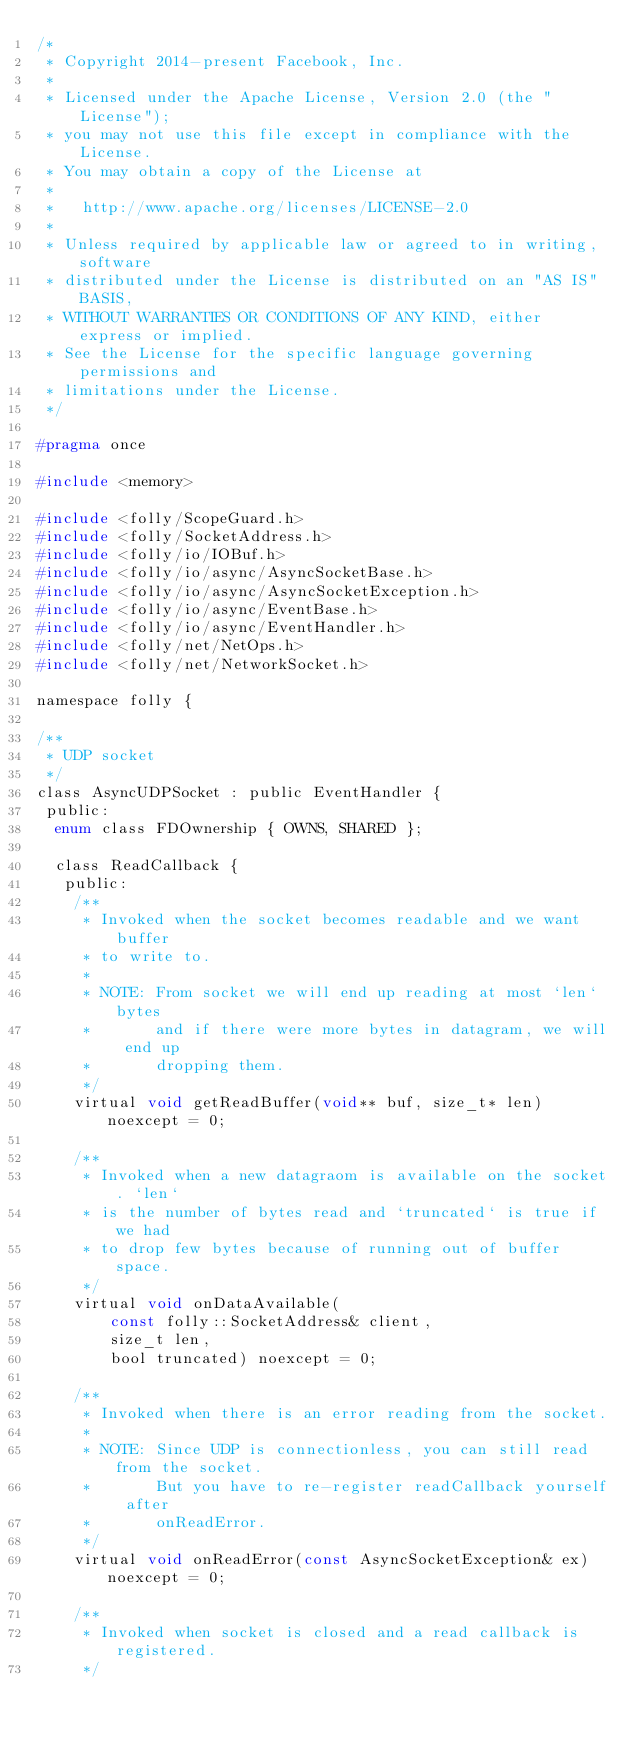<code> <loc_0><loc_0><loc_500><loc_500><_C_>/*
 * Copyright 2014-present Facebook, Inc.
 *
 * Licensed under the Apache License, Version 2.0 (the "License");
 * you may not use this file except in compliance with the License.
 * You may obtain a copy of the License at
 *
 *   http://www.apache.org/licenses/LICENSE-2.0
 *
 * Unless required by applicable law or agreed to in writing, software
 * distributed under the License is distributed on an "AS IS" BASIS,
 * WITHOUT WARRANTIES OR CONDITIONS OF ANY KIND, either express or implied.
 * See the License for the specific language governing permissions and
 * limitations under the License.
 */

#pragma once

#include <memory>

#include <folly/ScopeGuard.h>
#include <folly/SocketAddress.h>
#include <folly/io/IOBuf.h>
#include <folly/io/async/AsyncSocketBase.h>
#include <folly/io/async/AsyncSocketException.h>
#include <folly/io/async/EventBase.h>
#include <folly/io/async/EventHandler.h>
#include <folly/net/NetOps.h>
#include <folly/net/NetworkSocket.h>

namespace folly {

/**
 * UDP socket
 */
class AsyncUDPSocket : public EventHandler {
 public:
  enum class FDOwnership { OWNS, SHARED };

  class ReadCallback {
   public:
    /**
     * Invoked when the socket becomes readable and we want buffer
     * to write to.
     *
     * NOTE: From socket we will end up reading at most `len` bytes
     *       and if there were more bytes in datagram, we will end up
     *       dropping them.
     */
    virtual void getReadBuffer(void** buf, size_t* len) noexcept = 0;

    /**
     * Invoked when a new datagraom is available on the socket. `len`
     * is the number of bytes read and `truncated` is true if we had
     * to drop few bytes because of running out of buffer space.
     */
    virtual void onDataAvailable(
        const folly::SocketAddress& client,
        size_t len,
        bool truncated) noexcept = 0;

    /**
     * Invoked when there is an error reading from the socket.
     *
     * NOTE: Since UDP is connectionless, you can still read from the socket.
     *       But you have to re-register readCallback yourself after
     *       onReadError.
     */
    virtual void onReadError(const AsyncSocketException& ex) noexcept = 0;

    /**
     * Invoked when socket is closed and a read callback is registered.
     */</code> 